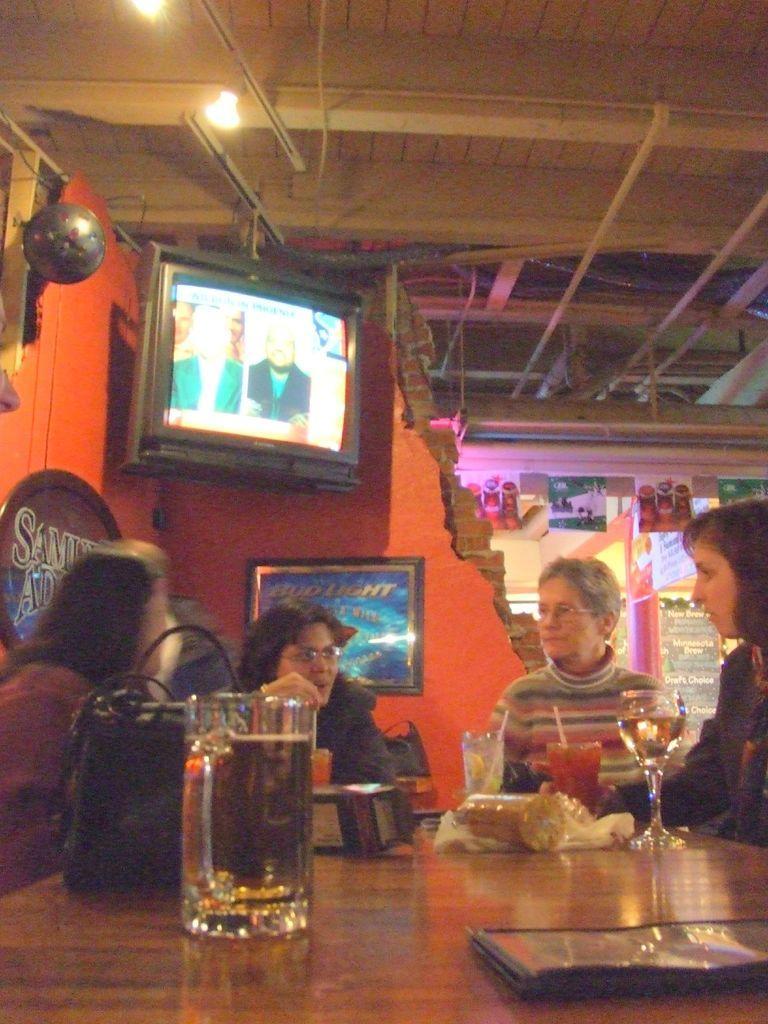In one or two sentences, can you explain what this image depicts? In this image I can see four people. In front of them there is a cup,glass,bag on the table. I can also see a board,television,light back side of them. 